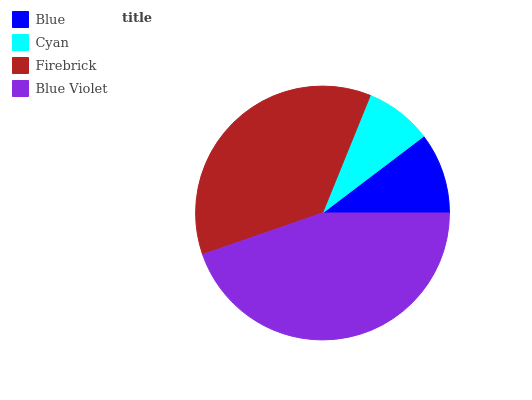Is Cyan the minimum?
Answer yes or no. Yes. Is Blue Violet the maximum?
Answer yes or no. Yes. Is Firebrick the minimum?
Answer yes or no. No. Is Firebrick the maximum?
Answer yes or no. No. Is Firebrick greater than Cyan?
Answer yes or no. Yes. Is Cyan less than Firebrick?
Answer yes or no. Yes. Is Cyan greater than Firebrick?
Answer yes or no. No. Is Firebrick less than Cyan?
Answer yes or no. No. Is Firebrick the high median?
Answer yes or no. Yes. Is Blue the low median?
Answer yes or no. Yes. Is Blue the high median?
Answer yes or no. No. Is Cyan the low median?
Answer yes or no. No. 